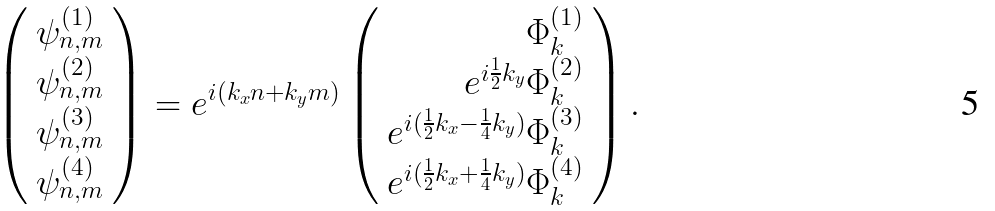Convert formula to latex. <formula><loc_0><loc_0><loc_500><loc_500>\left ( \begin{array} { c } \psi _ { n , m } ^ { ( 1 ) } \\ \psi _ { n , m } ^ { ( 2 ) } \\ \psi _ { n , m } ^ { ( 3 ) } \\ \psi _ { n , m } ^ { ( 4 ) } \end{array} \right ) = e ^ { i ( k _ { x } n + k _ { y } m ) } \left ( \begin{array} { r } \Phi _ { k } ^ { ( 1 ) } \\ e ^ { i \frac { 1 } { 2 } k _ { y } } \Phi _ { k } ^ { ( 2 ) } \\ e ^ { i ( \frac { 1 } { 2 } k _ { x } - \frac { 1 } { 4 } k _ { y } ) } \Phi _ { k } ^ { ( 3 ) } \\ e ^ { i ( \frac { 1 } { 2 } k _ { x } + \frac { 1 } { 4 } k _ { y } ) } \Phi _ { k } ^ { ( 4 ) } \end{array} \right ) .</formula> 